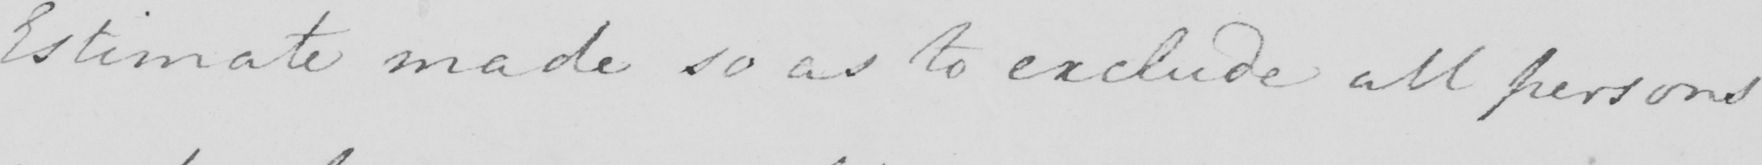Can you tell me what this handwritten text says? Estimate made so as to exclude all persons 